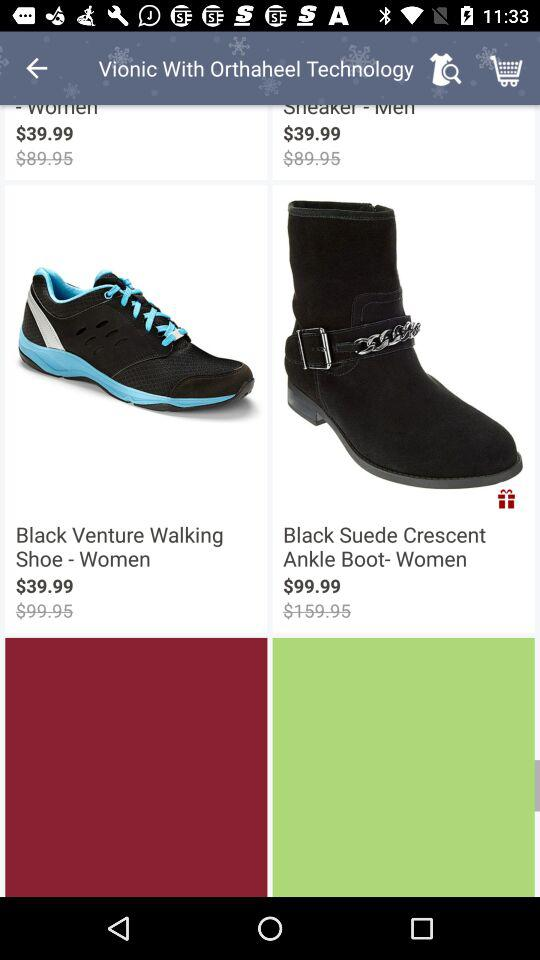What is the price of "Black Suede Crescent Ankle Boot- Women" after discount? The price of "Black Suede Crescent Ankle Boot- Women" after discount is 99.99 dollars. 